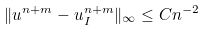<formula> <loc_0><loc_0><loc_500><loc_500>\| u ^ { n + m } - u _ { I } ^ { n + m } \| _ { \infty } \leq C n ^ { - 2 }</formula> 